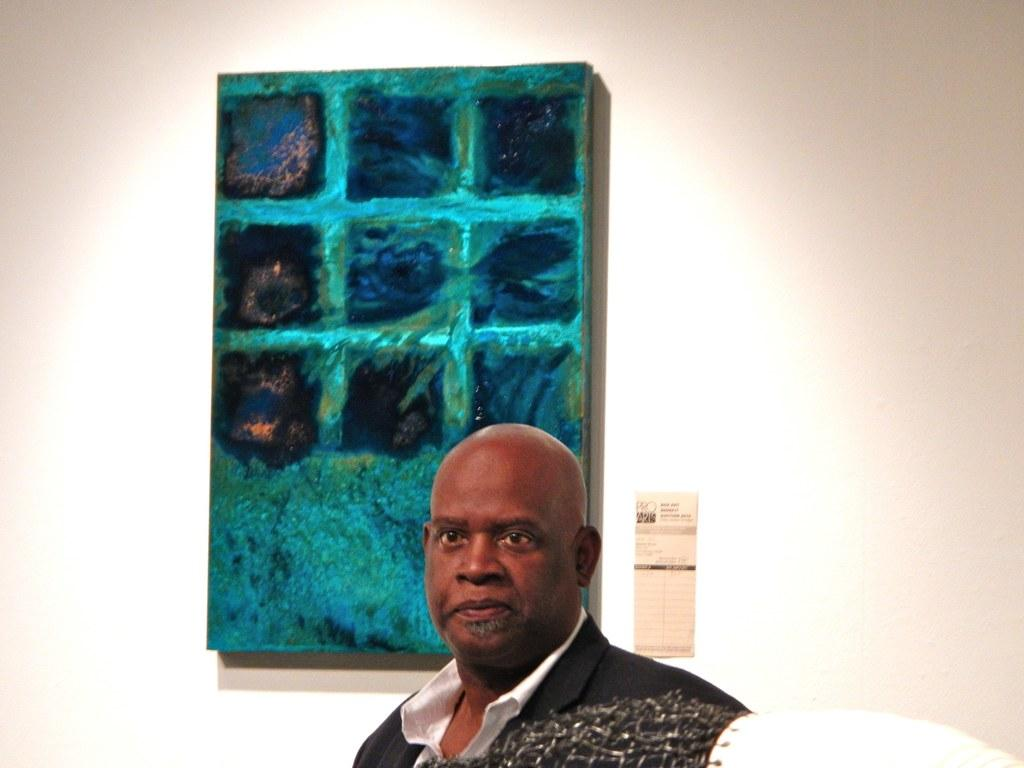What is the main subject of the image? There is a man standing in the image. Where is the man standing in relation to the place? The man is standing over a place. What can be seen on the wall behind the man? There is a painting on the wall behind the man. What type of crime is being committed in the image? There is no crime being committed in the image; it simply shows a man standing over a place with a painting on the wall behind him. 